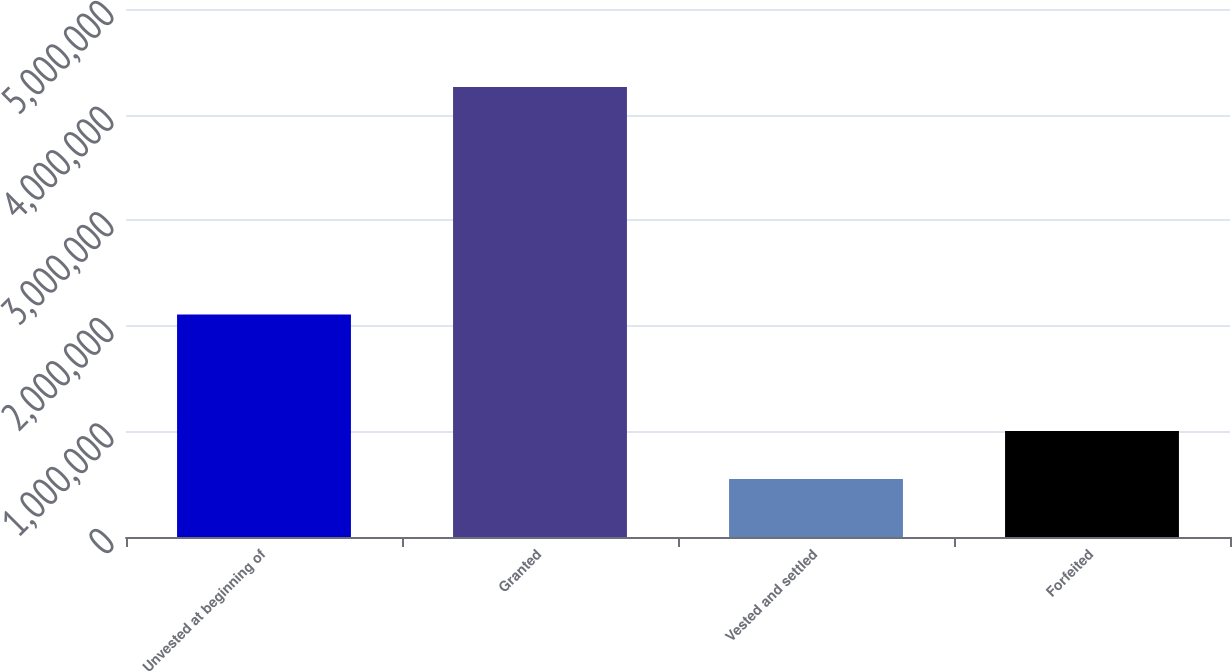Convert chart. <chart><loc_0><loc_0><loc_500><loc_500><bar_chart><fcel>Unvested at beginning of<fcel>Granted<fcel>Vested and settled<fcel>Forfeited<nl><fcel>2.10733e+06<fcel>4.26228e+06<fcel>548510<fcel>1.00423e+06<nl></chart> 